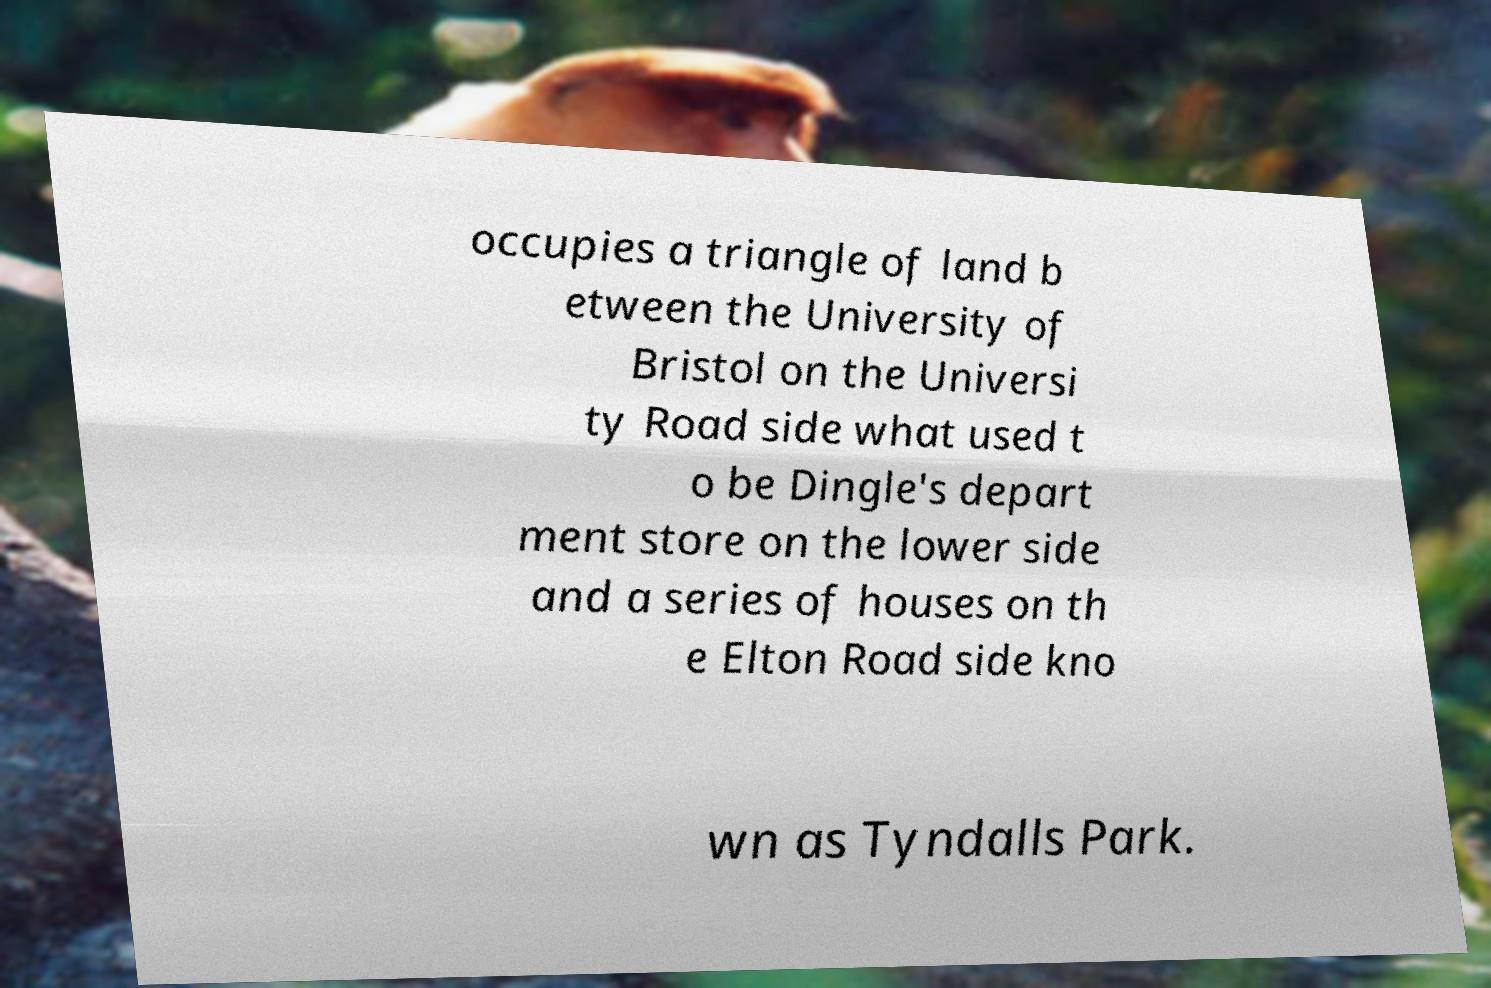Could you assist in decoding the text presented in this image and type it out clearly? occupies a triangle of land b etween the University of Bristol on the Universi ty Road side what used t o be Dingle's depart ment store on the lower side and a series of houses on th e Elton Road side kno wn as Tyndalls Park. 